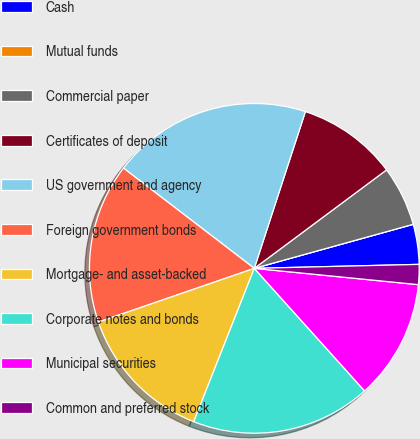Convert chart. <chart><loc_0><loc_0><loc_500><loc_500><pie_chart><fcel>Cash<fcel>Mutual funds<fcel>Commercial paper<fcel>Certificates of deposit<fcel>US government and agency<fcel>Foreign government bonds<fcel>Mortgage- and asset-backed<fcel>Corporate notes and bonds<fcel>Municipal securities<fcel>Common and preferred stock<nl><fcel>3.92%<fcel>0.0%<fcel>5.88%<fcel>9.8%<fcel>19.61%<fcel>15.69%<fcel>13.73%<fcel>17.65%<fcel>11.76%<fcel>1.96%<nl></chart> 